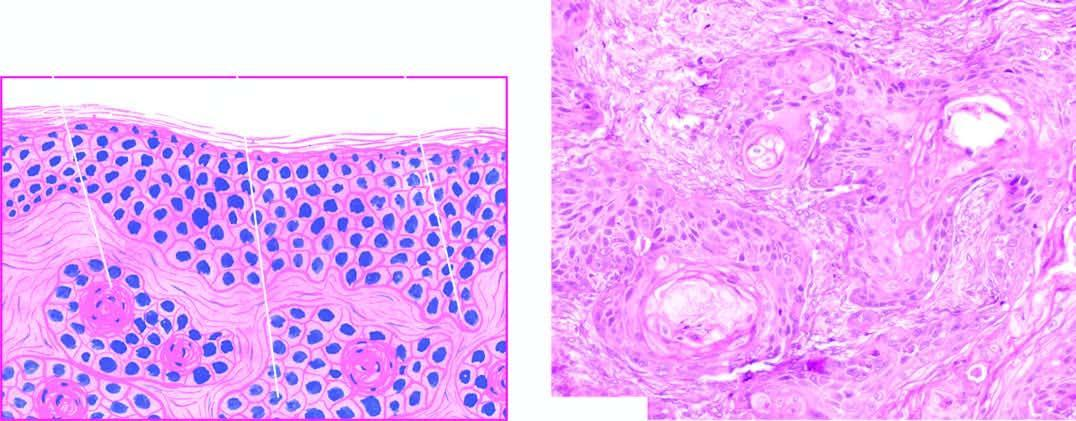re external surface shows present?
Answer the question using a single word or phrase. No 